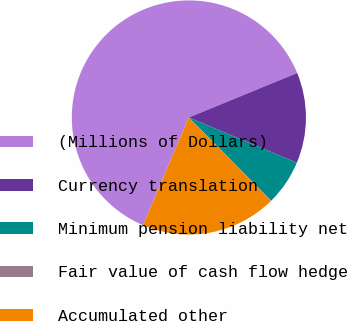<chart> <loc_0><loc_0><loc_500><loc_500><pie_chart><fcel>(Millions of Dollars)<fcel>Currency translation<fcel>Minimum pension liability net<fcel>Fair value of cash flow hedge<fcel>Accumulated other<nl><fcel>62.39%<fcel>12.52%<fcel>6.28%<fcel>0.05%<fcel>18.75%<nl></chart> 